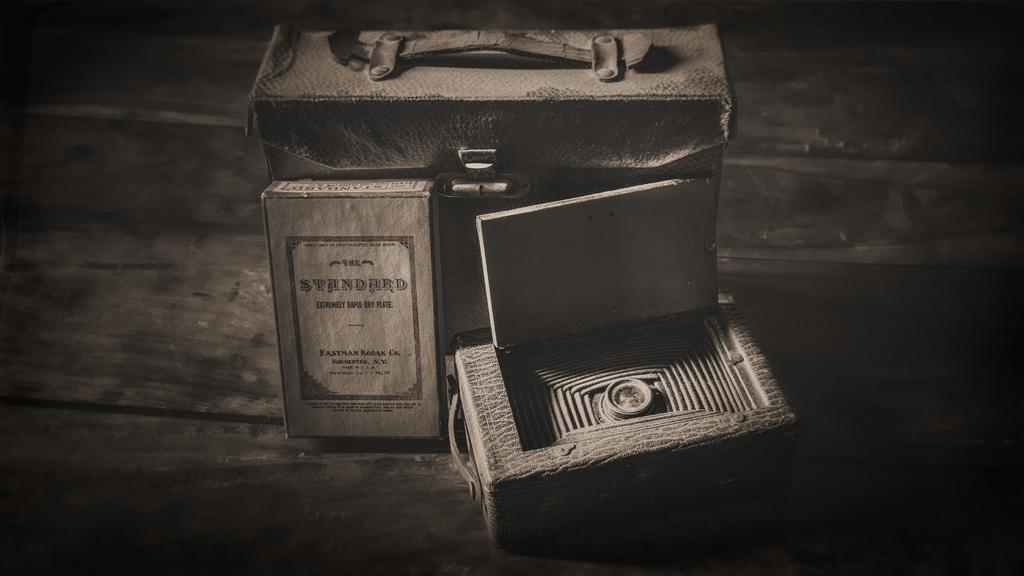Could you give a brief overview of what you see in this image? In this picture there is a bag and two boxes placed on the table. 